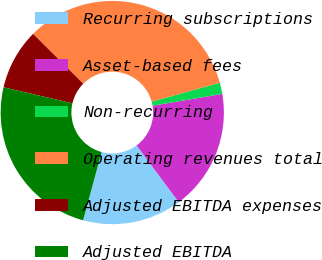Convert chart to OTSL. <chart><loc_0><loc_0><loc_500><loc_500><pie_chart><fcel>Recurring subscriptions<fcel>Asset-based fees<fcel>Non-recurring<fcel>Operating revenues total<fcel>Adjusted EBITDA expenses<fcel>Adjusted EBITDA<nl><fcel>14.36%<fcel>17.52%<fcel>1.63%<fcel>33.24%<fcel>8.82%<fcel>24.43%<nl></chart> 